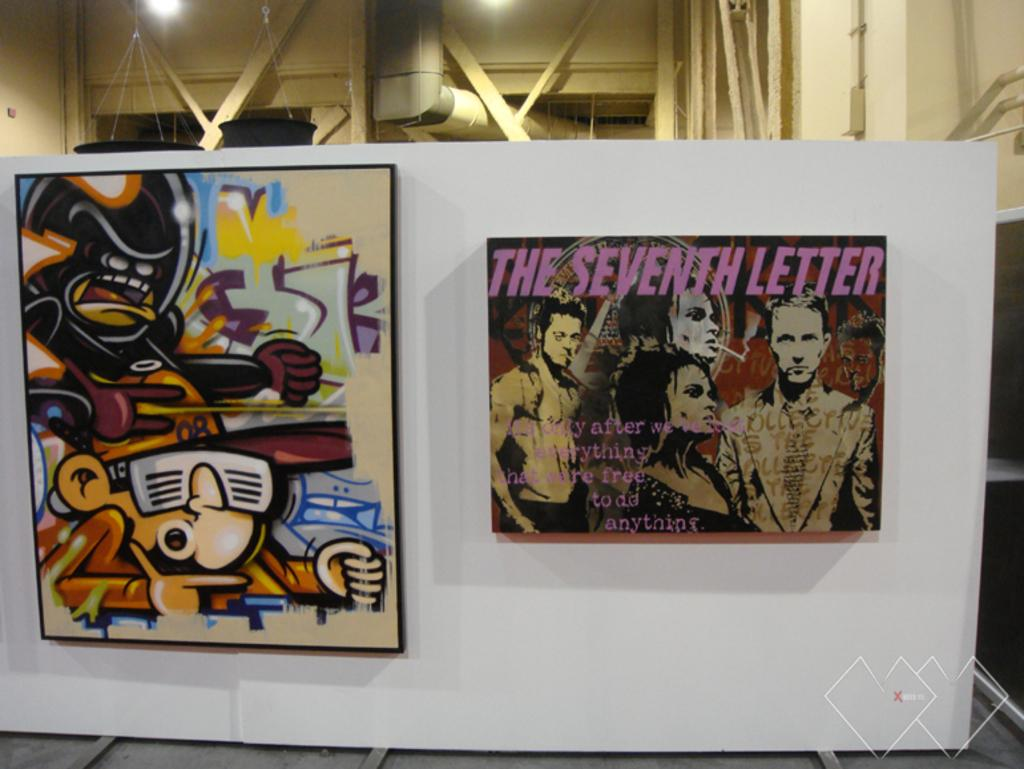<image>
Share a concise interpretation of the image provided. Two paintings next to one another with one saying "The Seventh Letter". 